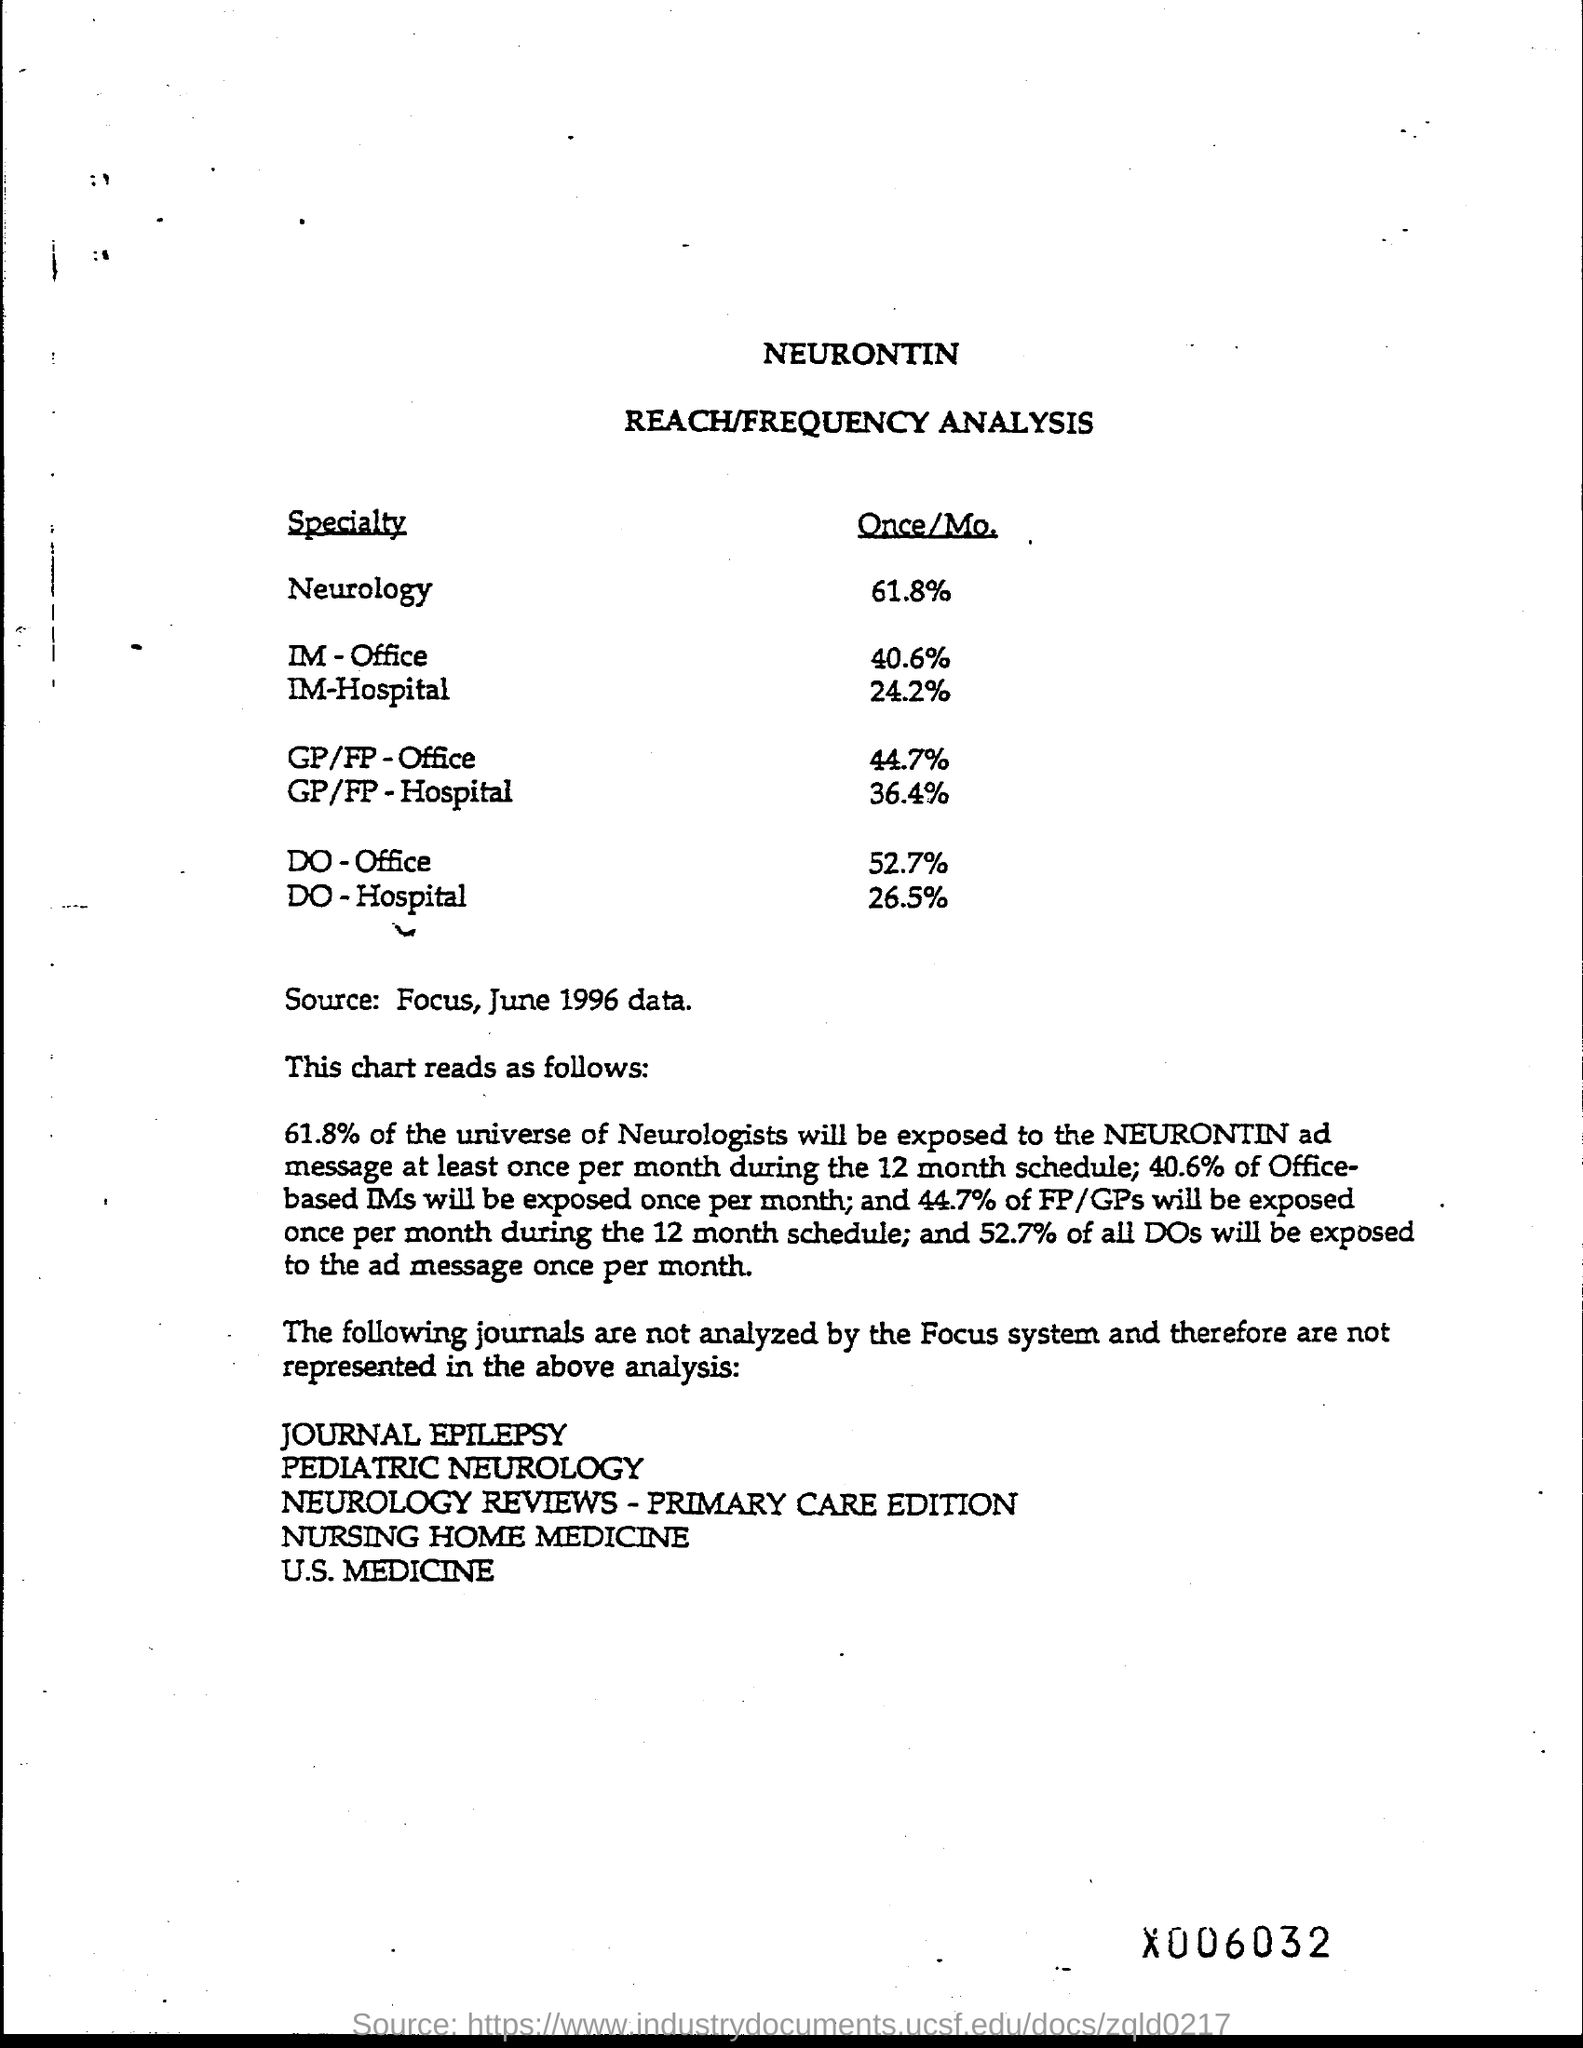What is the source?
Give a very brief answer. Focus, JUne 1996 data. 